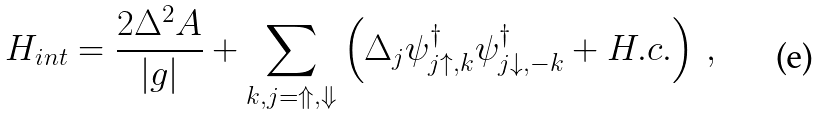Convert formula to latex. <formula><loc_0><loc_0><loc_500><loc_500>H _ { i n t } = \frac { 2 \Delta ^ { 2 } A } { \left | g \right | } + \sum _ { k , j = \Uparrow , \Downarrow } \left ( \Delta _ { j } { \psi } _ { j \uparrow , k } ^ { \dagger } { \psi } _ { j \downarrow , - k } ^ { \dagger } + H . c . \right ) \, ,</formula> 